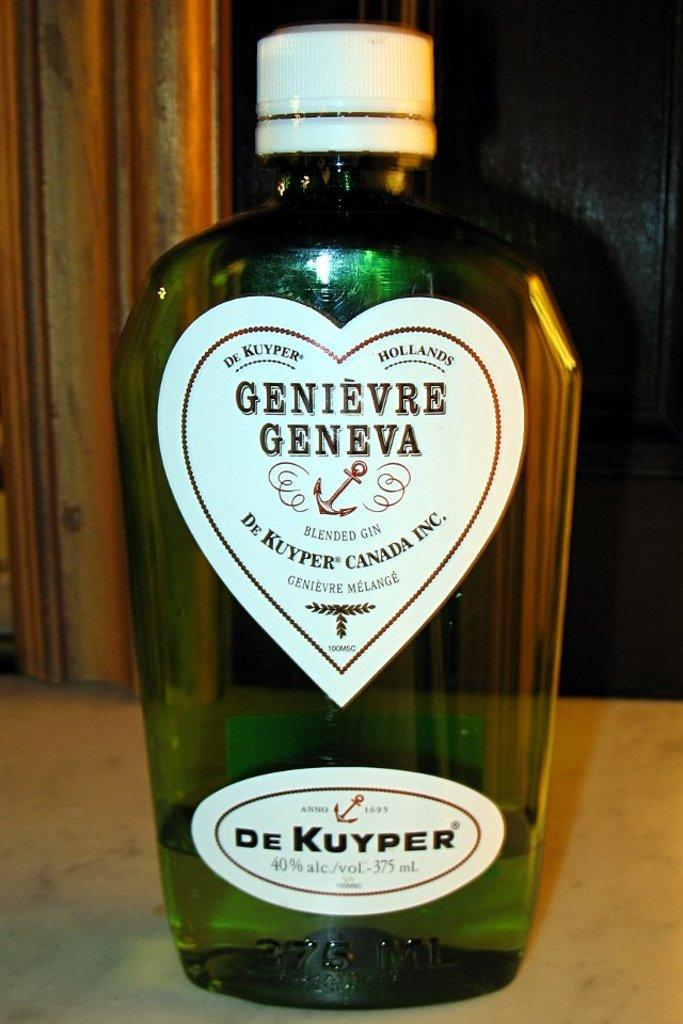What object can be seen in the image? There is a bottle in the image. Where is the bottle located? The bottle is placed on a table. What is the governor doing in the image? There is no governor present in the image; it only features a bottle placed on a table. 